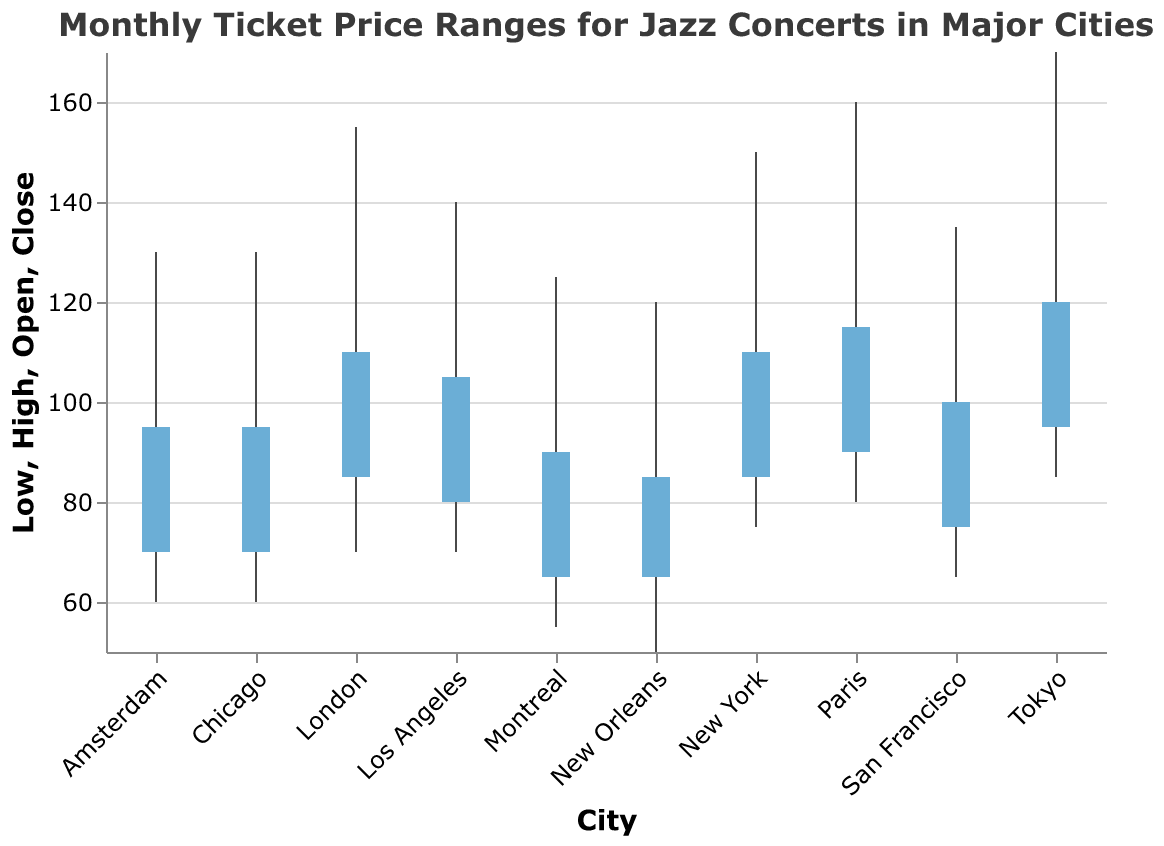What is the title of the figure? The title is at the top of the chart and typically summarizes the content or insight of the visual.
Answer: Monthly Ticket Price Ranges for Jazz Concerts in Major Cities Which city has the highest ticket price? Look for the city with the highest value on the y-axis for the "High" data point.
Answer: Tokyo What are the ticket price ranges for New York? Check the figure for the values corresponding to the low, open, close, and high for New York.
Answer: 75, 85, 110, 150 Which cities have a higher closing ticket price than New Orleans? Identify the Close value for New Orleans, and then compare the Close values for all other cities.
Answer: New York, Chicago, Los Angeles, San Francisco, Paris, London, Tokyo, Amsterdam Among Paris and London, which city has a higher opening ticket price? Compare the Open values for Paris and London.
Answer: Paris What is the average high ticket price for New York, Tokyo, and Paris? Sum the High values for these cities and divide by 3. The values are 150 (New York), 170 (Tokyo), and 160 (Paris). (150 + 170 + 160) / 3 = 480 / 3 = 160
Answer: 160 How much higher is the highest ticket price in Tokyo compared to Montreal? Subtract the High value of Montreal from the High value of Tokyo. The values are 170 (Tokyo) and 125 (Montreal). 170 - 125 = 45
Answer: 45 Which city has the smallest range of ticket prices? Calculate the range (High - Low) for each city and find the smallest value.
Answer: New Orleans Compare the closing prices of jazz concert tickets in Los Angeles and San Francisco. Which city has a higher closing price? Check the Close values for both cities and compare them.
Answer: Los Angeles What is the overall trend in ticket prices for jazz concerts across these major cities? Look at the overall range and spread of prices in the chart to see if there is a general trend, such as an increase or decrease.
Answer: Typically high in larger, international cities 